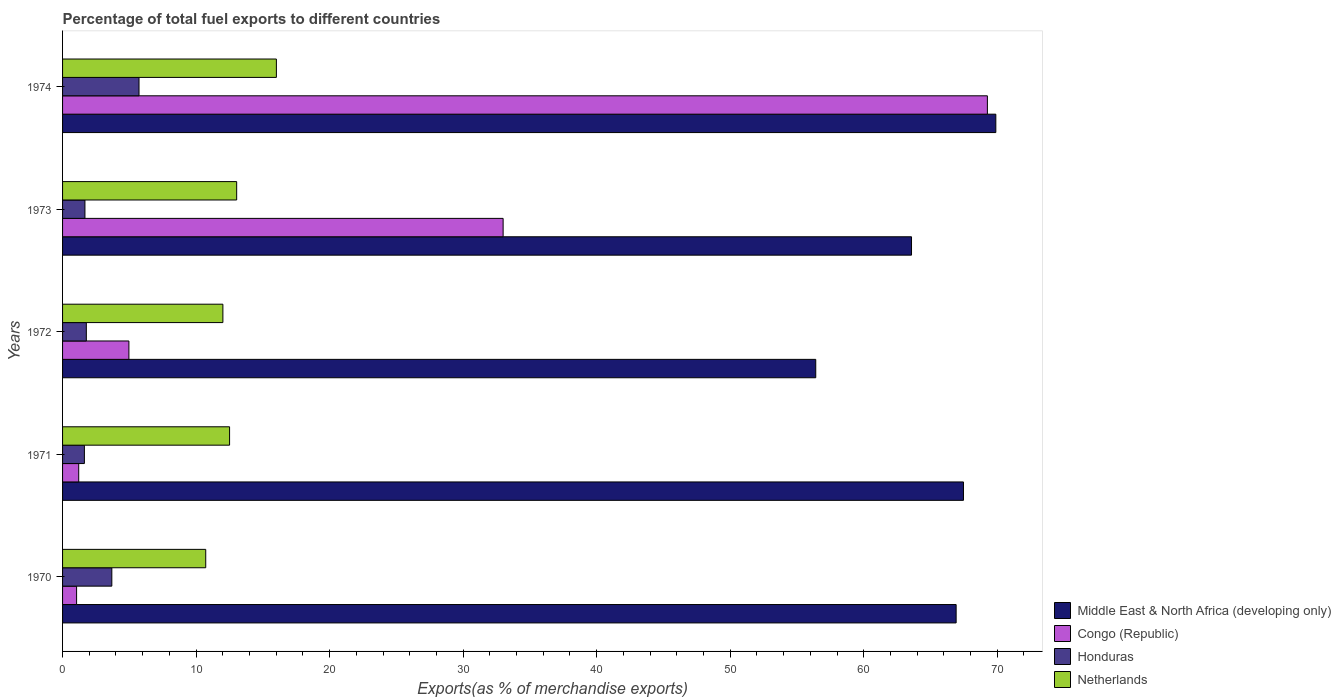How many different coloured bars are there?
Provide a succinct answer. 4. How many groups of bars are there?
Provide a short and direct response. 5. Are the number of bars on each tick of the Y-axis equal?
Your answer should be compact. Yes. How many bars are there on the 4th tick from the top?
Your answer should be compact. 4. How many bars are there on the 3rd tick from the bottom?
Give a very brief answer. 4. What is the percentage of exports to different countries in Middle East & North Africa (developing only) in 1971?
Provide a short and direct response. 67.47. Across all years, what is the maximum percentage of exports to different countries in Middle East & North Africa (developing only)?
Your answer should be compact. 69.9. Across all years, what is the minimum percentage of exports to different countries in Honduras?
Make the answer very short. 1.64. In which year was the percentage of exports to different countries in Netherlands maximum?
Provide a succinct answer. 1974. What is the total percentage of exports to different countries in Honduras in the graph?
Make the answer very short. 14.51. What is the difference between the percentage of exports to different countries in Netherlands in 1970 and that in 1972?
Offer a very short reply. -1.29. What is the difference between the percentage of exports to different countries in Netherlands in 1973 and the percentage of exports to different countries in Honduras in 1972?
Your response must be concise. 11.26. What is the average percentage of exports to different countries in Netherlands per year?
Offer a terse response. 12.86. In the year 1972, what is the difference between the percentage of exports to different countries in Middle East & North Africa (developing only) and percentage of exports to different countries in Netherlands?
Provide a succinct answer. 44.4. What is the ratio of the percentage of exports to different countries in Netherlands in 1973 to that in 1974?
Your response must be concise. 0.81. Is the percentage of exports to different countries in Middle East & North Africa (developing only) in 1970 less than that in 1972?
Your answer should be very brief. No. Is the difference between the percentage of exports to different countries in Middle East & North Africa (developing only) in 1971 and 1974 greater than the difference between the percentage of exports to different countries in Netherlands in 1971 and 1974?
Give a very brief answer. Yes. What is the difference between the highest and the second highest percentage of exports to different countries in Honduras?
Make the answer very short. 2.04. What is the difference between the highest and the lowest percentage of exports to different countries in Congo (Republic)?
Offer a very short reply. 68.21. Is the sum of the percentage of exports to different countries in Netherlands in 1971 and 1974 greater than the maximum percentage of exports to different countries in Honduras across all years?
Give a very brief answer. Yes. What does the 4th bar from the top in 1970 represents?
Give a very brief answer. Middle East & North Africa (developing only). What does the 1st bar from the bottom in 1970 represents?
Your answer should be very brief. Middle East & North Africa (developing only). Is it the case that in every year, the sum of the percentage of exports to different countries in Congo (Republic) and percentage of exports to different countries in Netherlands is greater than the percentage of exports to different countries in Honduras?
Offer a very short reply. Yes. Are all the bars in the graph horizontal?
Your answer should be very brief. Yes. What is the difference between two consecutive major ticks on the X-axis?
Your answer should be compact. 10. Are the values on the major ticks of X-axis written in scientific E-notation?
Ensure brevity in your answer.  No. Does the graph contain any zero values?
Your response must be concise. No. How many legend labels are there?
Provide a short and direct response. 4. What is the title of the graph?
Provide a succinct answer. Percentage of total fuel exports to different countries. Does "Cuba" appear as one of the legend labels in the graph?
Keep it short and to the point. No. What is the label or title of the X-axis?
Provide a short and direct response. Exports(as % of merchandise exports). What is the Exports(as % of merchandise exports) in Middle East & North Africa (developing only) in 1970?
Give a very brief answer. 66.92. What is the Exports(as % of merchandise exports) of Congo (Republic) in 1970?
Offer a terse response. 1.05. What is the Exports(as % of merchandise exports) in Honduras in 1970?
Keep it short and to the point. 3.69. What is the Exports(as % of merchandise exports) in Netherlands in 1970?
Ensure brevity in your answer.  10.72. What is the Exports(as % of merchandise exports) of Middle East & North Africa (developing only) in 1971?
Your response must be concise. 67.47. What is the Exports(as % of merchandise exports) in Congo (Republic) in 1971?
Provide a succinct answer. 1.21. What is the Exports(as % of merchandise exports) in Honduras in 1971?
Offer a terse response. 1.64. What is the Exports(as % of merchandise exports) in Netherlands in 1971?
Offer a very short reply. 12.51. What is the Exports(as % of merchandise exports) of Middle East & North Africa (developing only) in 1972?
Your answer should be compact. 56.41. What is the Exports(as % of merchandise exports) in Congo (Republic) in 1972?
Offer a very short reply. 4.97. What is the Exports(as % of merchandise exports) of Honduras in 1972?
Make the answer very short. 1.78. What is the Exports(as % of merchandise exports) in Netherlands in 1972?
Provide a short and direct response. 12.01. What is the Exports(as % of merchandise exports) of Middle East & North Africa (developing only) in 1973?
Your answer should be very brief. 63.58. What is the Exports(as % of merchandise exports) in Congo (Republic) in 1973?
Make the answer very short. 33. What is the Exports(as % of merchandise exports) of Honduras in 1973?
Offer a very short reply. 1.67. What is the Exports(as % of merchandise exports) in Netherlands in 1973?
Give a very brief answer. 13.04. What is the Exports(as % of merchandise exports) in Middle East & North Africa (developing only) in 1974?
Keep it short and to the point. 69.9. What is the Exports(as % of merchandise exports) of Congo (Republic) in 1974?
Ensure brevity in your answer.  69.26. What is the Exports(as % of merchandise exports) of Honduras in 1974?
Make the answer very short. 5.73. What is the Exports(as % of merchandise exports) in Netherlands in 1974?
Give a very brief answer. 16.01. Across all years, what is the maximum Exports(as % of merchandise exports) of Middle East & North Africa (developing only)?
Keep it short and to the point. 69.9. Across all years, what is the maximum Exports(as % of merchandise exports) of Congo (Republic)?
Make the answer very short. 69.26. Across all years, what is the maximum Exports(as % of merchandise exports) in Honduras?
Provide a succinct answer. 5.73. Across all years, what is the maximum Exports(as % of merchandise exports) in Netherlands?
Make the answer very short. 16.01. Across all years, what is the minimum Exports(as % of merchandise exports) of Middle East & North Africa (developing only)?
Offer a terse response. 56.41. Across all years, what is the minimum Exports(as % of merchandise exports) in Congo (Republic)?
Provide a short and direct response. 1.05. Across all years, what is the minimum Exports(as % of merchandise exports) of Honduras?
Your answer should be very brief. 1.64. Across all years, what is the minimum Exports(as % of merchandise exports) of Netherlands?
Ensure brevity in your answer.  10.72. What is the total Exports(as % of merchandise exports) in Middle East & North Africa (developing only) in the graph?
Your response must be concise. 324.28. What is the total Exports(as % of merchandise exports) of Congo (Republic) in the graph?
Offer a terse response. 109.49. What is the total Exports(as % of merchandise exports) in Honduras in the graph?
Provide a succinct answer. 14.51. What is the total Exports(as % of merchandise exports) in Netherlands in the graph?
Ensure brevity in your answer.  64.29. What is the difference between the Exports(as % of merchandise exports) in Middle East & North Africa (developing only) in 1970 and that in 1971?
Offer a very short reply. -0.55. What is the difference between the Exports(as % of merchandise exports) in Congo (Republic) in 1970 and that in 1971?
Provide a short and direct response. -0.16. What is the difference between the Exports(as % of merchandise exports) of Honduras in 1970 and that in 1971?
Ensure brevity in your answer.  2.05. What is the difference between the Exports(as % of merchandise exports) of Netherlands in 1970 and that in 1971?
Provide a succinct answer. -1.79. What is the difference between the Exports(as % of merchandise exports) in Middle East & North Africa (developing only) in 1970 and that in 1972?
Ensure brevity in your answer.  10.51. What is the difference between the Exports(as % of merchandise exports) in Congo (Republic) in 1970 and that in 1972?
Offer a very short reply. -3.92. What is the difference between the Exports(as % of merchandise exports) in Honduras in 1970 and that in 1972?
Your answer should be very brief. 1.91. What is the difference between the Exports(as % of merchandise exports) in Netherlands in 1970 and that in 1972?
Your answer should be compact. -1.29. What is the difference between the Exports(as % of merchandise exports) in Middle East & North Africa (developing only) in 1970 and that in 1973?
Ensure brevity in your answer.  3.34. What is the difference between the Exports(as % of merchandise exports) of Congo (Republic) in 1970 and that in 1973?
Your answer should be very brief. -31.94. What is the difference between the Exports(as % of merchandise exports) in Honduras in 1970 and that in 1973?
Make the answer very short. 2.01. What is the difference between the Exports(as % of merchandise exports) in Netherlands in 1970 and that in 1973?
Offer a terse response. -2.32. What is the difference between the Exports(as % of merchandise exports) of Middle East & North Africa (developing only) in 1970 and that in 1974?
Keep it short and to the point. -2.97. What is the difference between the Exports(as % of merchandise exports) in Congo (Republic) in 1970 and that in 1974?
Keep it short and to the point. -68.21. What is the difference between the Exports(as % of merchandise exports) in Honduras in 1970 and that in 1974?
Make the answer very short. -2.04. What is the difference between the Exports(as % of merchandise exports) of Netherlands in 1970 and that in 1974?
Make the answer very short. -5.29. What is the difference between the Exports(as % of merchandise exports) of Middle East & North Africa (developing only) in 1971 and that in 1972?
Give a very brief answer. 11.06. What is the difference between the Exports(as % of merchandise exports) of Congo (Republic) in 1971 and that in 1972?
Your answer should be compact. -3.76. What is the difference between the Exports(as % of merchandise exports) in Honduras in 1971 and that in 1972?
Provide a short and direct response. -0.14. What is the difference between the Exports(as % of merchandise exports) in Netherlands in 1971 and that in 1972?
Offer a very short reply. 0.5. What is the difference between the Exports(as % of merchandise exports) of Middle East & North Africa (developing only) in 1971 and that in 1973?
Your response must be concise. 3.89. What is the difference between the Exports(as % of merchandise exports) of Congo (Republic) in 1971 and that in 1973?
Offer a very short reply. -31.79. What is the difference between the Exports(as % of merchandise exports) of Honduras in 1971 and that in 1973?
Your answer should be very brief. -0.04. What is the difference between the Exports(as % of merchandise exports) of Netherlands in 1971 and that in 1973?
Your answer should be compact. -0.53. What is the difference between the Exports(as % of merchandise exports) in Middle East & North Africa (developing only) in 1971 and that in 1974?
Your answer should be compact. -2.42. What is the difference between the Exports(as % of merchandise exports) in Congo (Republic) in 1971 and that in 1974?
Keep it short and to the point. -68.05. What is the difference between the Exports(as % of merchandise exports) in Honduras in 1971 and that in 1974?
Make the answer very short. -4.09. What is the difference between the Exports(as % of merchandise exports) of Netherlands in 1971 and that in 1974?
Your answer should be compact. -3.51. What is the difference between the Exports(as % of merchandise exports) in Middle East & North Africa (developing only) in 1972 and that in 1973?
Offer a very short reply. -7.17. What is the difference between the Exports(as % of merchandise exports) of Congo (Republic) in 1972 and that in 1973?
Your answer should be compact. -28.03. What is the difference between the Exports(as % of merchandise exports) in Honduras in 1972 and that in 1973?
Offer a terse response. 0.1. What is the difference between the Exports(as % of merchandise exports) in Netherlands in 1972 and that in 1973?
Your answer should be compact. -1.03. What is the difference between the Exports(as % of merchandise exports) in Middle East & North Africa (developing only) in 1972 and that in 1974?
Provide a short and direct response. -13.49. What is the difference between the Exports(as % of merchandise exports) of Congo (Republic) in 1972 and that in 1974?
Make the answer very short. -64.3. What is the difference between the Exports(as % of merchandise exports) in Honduras in 1972 and that in 1974?
Offer a terse response. -3.95. What is the difference between the Exports(as % of merchandise exports) of Netherlands in 1972 and that in 1974?
Keep it short and to the point. -4.01. What is the difference between the Exports(as % of merchandise exports) of Middle East & North Africa (developing only) in 1973 and that in 1974?
Keep it short and to the point. -6.31. What is the difference between the Exports(as % of merchandise exports) in Congo (Republic) in 1973 and that in 1974?
Ensure brevity in your answer.  -36.27. What is the difference between the Exports(as % of merchandise exports) of Honduras in 1973 and that in 1974?
Offer a terse response. -4.05. What is the difference between the Exports(as % of merchandise exports) of Netherlands in 1973 and that in 1974?
Offer a terse response. -2.97. What is the difference between the Exports(as % of merchandise exports) in Middle East & North Africa (developing only) in 1970 and the Exports(as % of merchandise exports) in Congo (Republic) in 1971?
Your response must be concise. 65.71. What is the difference between the Exports(as % of merchandise exports) of Middle East & North Africa (developing only) in 1970 and the Exports(as % of merchandise exports) of Honduras in 1971?
Offer a terse response. 65.29. What is the difference between the Exports(as % of merchandise exports) of Middle East & North Africa (developing only) in 1970 and the Exports(as % of merchandise exports) of Netherlands in 1971?
Give a very brief answer. 54.42. What is the difference between the Exports(as % of merchandise exports) in Congo (Republic) in 1970 and the Exports(as % of merchandise exports) in Honduras in 1971?
Make the answer very short. -0.58. What is the difference between the Exports(as % of merchandise exports) in Congo (Republic) in 1970 and the Exports(as % of merchandise exports) in Netherlands in 1971?
Provide a succinct answer. -11.46. What is the difference between the Exports(as % of merchandise exports) of Honduras in 1970 and the Exports(as % of merchandise exports) of Netherlands in 1971?
Ensure brevity in your answer.  -8.82. What is the difference between the Exports(as % of merchandise exports) in Middle East & North Africa (developing only) in 1970 and the Exports(as % of merchandise exports) in Congo (Republic) in 1972?
Your answer should be very brief. 61.95. What is the difference between the Exports(as % of merchandise exports) of Middle East & North Africa (developing only) in 1970 and the Exports(as % of merchandise exports) of Honduras in 1972?
Your answer should be very brief. 65.14. What is the difference between the Exports(as % of merchandise exports) of Middle East & North Africa (developing only) in 1970 and the Exports(as % of merchandise exports) of Netherlands in 1972?
Provide a succinct answer. 54.92. What is the difference between the Exports(as % of merchandise exports) in Congo (Republic) in 1970 and the Exports(as % of merchandise exports) in Honduras in 1972?
Offer a terse response. -0.73. What is the difference between the Exports(as % of merchandise exports) of Congo (Republic) in 1970 and the Exports(as % of merchandise exports) of Netherlands in 1972?
Keep it short and to the point. -10.96. What is the difference between the Exports(as % of merchandise exports) of Honduras in 1970 and the Exports(as % of merchandise exports) of Netherlands in 1972?
Your response must be concise. -8.32. What is the difference between the Exports(as % of merchandise exports) in Middle East & North Africa (developing only) in 1970 and the Exports(as % of merchandise exports) in Congo (Republic) in 1973?
Give a very brief answer. 33.93. What is the difference between the Exports(as % of merchandise exports) in Middle East & North Africa (developing only) in 1970 and the Exports(as % of merchandise exports) in Honduras in 1973?
Provide a short and direct response. 65.25. What is the difference between the Exports(as % of merchandise exports) of Middle East & North Africa (developing only) in 1970 and the Exports(as % of merchandise exports) of Netherlands in 1973?
Ensure brevity in your answer.  53.88. What is the difference between the Exports(as % of merchandise exports) of Congo (Republic) in 1970 and the Exports(as % of merchandise exports) of Honduras in 1973?
Your response must be concise. -0.62. What is the difference between the Exports(as % of merchandise exports) in Congo (Republic) in 1970 and the Exports(as % of merchandise exports) in Netherlands in 1973?
Your answer should be very brief. -11.99. What is the difference between the Exports(as % of merchandise exports) in Honduras in 1970 and the Exports(as % of merchandise exports) in Netherlands in 1973?
Offer a terse response. -9.35. What is the difference between the Exports(as % of merchandise exports) of Middle East & North Africa (developing only) in 1970 and the Exports(as % of merchandise exports) of Congo (Republic) in 1974?
Your answer should be compact. -2.34. What is the difference between the Exports(as % of merchandise exports) of Middle East & North Africa (developing only) in 1970 and the Exports(as % of merchandise exports) of Honduras in 1974?
Your answer should be very brief. 61.2. What is the difference between the Exports(as % of merchandise exports) of Middle East & North Africa (developing only) in 1970 and the Exports(as % of merchandise exports) of Netherlands in 1974?
Offer a terse response. 50.91. What is the difference between the Exports(as % of merchandise exports) of Congo (Republic) in 1970 and the Exports(as % of merchandise exports) of Honduras in 1974?
Provide a succinct answer. -4.68. What is the difference between the Exports(as % of merchandise exports) of Congo (Republic) in 1970 and the Exports(as % of merchandise exports) of Netherlands in 1974?
Provide a short and direct response. -14.96. What is the difference between the Exports(as % of merchandise exports) of Honduras in 1970 and the Exports(as % of merchandise exports) of Netherlands in 1974?
Your answer should be compact. -12.32. What is the difference between the Exports(as % of merchandise exports) in Middle East & North Africa (developing only) in 1971 and the Exports(as % of merchandise exports) in Congo (Republic) in 1972?
Your response must be concise. 62.5. What is the difference between the Exports(as % of merchandise exports) in Middle East & North Africa (developing only) in 1971 and the Exports(as % of merchandise exports) in Honduras in 1972?
Your answer should be very brief. 65.69. What is the difference between the Exports(as % of merchandise exports) of Middle East & North Africa (developing only) in 1971 and the Exports(as % of merchandise exports) of Netherlands in 1972?
Give a very brief answer. 55.46. What is the difference between the Exports(as % of merchandise exports) of Congo (Republic) in 1971 and the Exports(as % of merchandise exports) of Honduras in 1972?
Keep it short and to the point. -0.57. What is the difference between the Exports(as % of merchandise exports) of Congo (Republic) in 1971 and the Exports(as % of merchandise exports) of Netherlands in 1972?
Ensure brevity in your answer.  -10.8. What is the difference between the Exports(as % of merchandise exports) of Honduras in 1971 and the Exports(as % of merchandise exports) of Netherlands in 1972?
Provide a short and direct response. -10.37. What is the difference between the Exports(as % of merchandise exports) of Middle East & North Africa (developing only) in 1971 and the Exports(as % of merchandise exports) of Congo (Republic) in 1973?
Ensure brevity in your answer.  34.48. What is the difference between the Exports(as % of merchandise exports) in Middle East & North Africa (developing only) in 1971 and the Exports(as % of merchandise exports) in Honduras in 1973?
Offer a very short reply. 65.8. What is the difference between the Exports(as % of merchandise exports) in Middle East & North Africa (developing only) in 1971 and the Exports(as % of merchandise exports) in Netherlands in 1973?
Ensure brevity in your answer.  54.43. What is the difference between the Exports(as % of merchandise exports) of Congo (Republic) in 1971 and the Exports(as % of merchandise exports) of Honduras in 1973?
Your response must be concise. -0.47. What is the difference between the Exports(as % of merchandise exports) of Congo (Republic) in 1971 and the Exports(as % of merchandise exports) of Netherlands in 1973?
Your answer should be compact. -11.83. What is the difference between the Exports(as % of merchandise exports) of Honduras in 1971 and the Exports(as % of merchandise exports) of Netherlands in 1973?
Ensure brevity in your answer.  -11.4. What is the difference between the Exports(as % of merchandise exports) in Middle East & North Africa (developing only) in 1971 and the Exports(as % of merchandise exports) in Congo (Republic) in 1974?
Make the answer very short. -1.79. What is the difference between the Exports(as % of merchandise exports) in Middle East & North Africa (developing only) in 1971 and the Exports(as % of merchandise exports) in Honduras in 1974?
Give a very brief answer. 61.75. What is the difference between the Exports(as % of merchandise exports) in Middle East & North Africa (developing only) in 1971 and the Exports(as % of merchandise exports) in Netherlands in 1974?
Keep it short and to the point. 51.46. What is the difference between the Exports(as % of merchandise exports) of Congo (Republic) in 1971 and the Exports(as % of merchandise exports) of Honduras in 1974?
Your answer should be very brief. -4.52. What is the difference between the Exports(as % of merchandise exports) of Congo (Republic) in 1971 and the Exports(as % of merchandise exports) of Netherlands in 1974?
Your answer should be compact. -14.8. What is the difference between the Exports(as % of merchandise exports) in Honduras in 1971 and the Exports(as % of merchandise exports) in Netherlands in 1974?
Provide a short and direct response. -14.38. What is the difference between the Exports(as % of merchandise exports) in Middle East & North Africa (developing only) in 1972 and the Exports(as % of merchandise exports) in Congo (Republic) in 1973?
Offer a terse response. 23.41. What is the difference between the Exports(as % of merchandise exports) in Middle East & North Africa (developing only) in 1972 and the Exports(as % of merchandise exports) in Honduras in 1973?
Your response must be concise. 54.73. What is the difference between the Exports(as % of merchandise exports) of Middle East & North Africa (developing only) in 1972 and the Exports(as % of merchandise exports) of Netherlands in 1973?
Ensure brevity in your answer.  43.37. What is the difference between the Exports(as % of merchandise exports) in Congo (Republic) in 1972 and the Exports(as % of merchandise exports) in Honduras in 1973?
Your response must be concise. 3.29. What is the difference between the Exports(as % of merchandise exports) of Congo (Republic) in 1972 and the Exports(as % of merchandise exports) of Netherlands in 1973?
Your answer should be very brief. -8.07. What is the difference between the Exports(as % of merchandise exports) in Honduras in 1972 and the Exports(as % of merchandise exports) in Netherlands in 1973?
Make the answer very short. -11.26. What is the difference between the Exports(as % of merchandise exports) in Middle East & North Africa (developing only) in 1972 and the Exports(as % of merchandise exports) in Congo (Republic) in 1974?
Keep it short and to the point. -12.86. What is the difference between the Exports(as % of merchandise exports) of Middle East & North Africa (developing only) in 1972 and the Exports(as % of merchandise exports) of Honduras in 1974?
Provide a succinct answer. 50.68. What is the difference between the Exports(as % of merchandise exports) of Middle East & North Africa (developing only) in 1972 and the Exports(as % of merchandise exports) of Netherlands in 1974?
Provide a short and direct response. 40.39. What is the difference between the Exports(as % of merchandise exports) of Congo (Republic) in 1972 and the Exports(as % of merchandise exports) of Honduras in 1974?
Your answer should be compact. -0.76. What is the difference between the Exports(as % of merchandise exports) in Congo (Republic) in 1972 and the Exports(as % of merchandise exports) in Netherlands in 1974?
Provide a short and direct response. -11.05. What is the difference between the Exports(as % of merchandise exports) in Honduras in 1972 and the Exports(as % of merchandise exports) in Netherlands in 1974?
Give a very brief answer. -14.23. What is the difference between the Exports(as % of merchandise exports) of Middle East & North Africa (developing only) in 1973 and the Exports(as % of merchandise exports) of Congo (Republic) in 1974?
Your response must be concise. -5.68. What is the difference between the Exports(as % of merchandise exports) in Middle East & North Africa (developing only) in 1973 and the Exports(as % of merchandise exports) in Honduras in 1974?
Your answer should be very brief. 57.85. What is the difference between the Exports(as % of merchandise exports) of Middle East & North Africa (developing only) in 1973 and the Exports(as % of merchandise exports) of Netherlands in 1974?
Keep it short and to the point. 47.57. What is the difference between the Exports(as % of merchandise exports) of Congo (Republic) in 1973 and the Exports(as % of merchandise exports) of Honduras in 1974?
Your answer should be very brief. 27.27. What is the difference between the Exports(as % of merchandise exports) in Congo (Republic) in 1973 and the Exports(as % of merchandise exports) in Netherlands in 1974?
Your answer should be compact. 16.98. What is the difference between the Exports(as % of merchandise exports) in Honduras in 1973 and the Exports(as % of merchandise exports) in Netherlands in 1974?
Your answer should be compact. -14.34. What is the average Exports(as % of merchandise exports) in Middle East & North Africa (developing only) per year?
Your response must be concise. 64.86. What is the average Exports(as % of merchandise exports) in Congo (Republic) per year?
Provide a short and direct response. 21.9. What is the average Exports(as % of merchandise exports) of Honduras per year?
Your answer should be compact. 2.9. What is the average Exports(as % of merchandise exports) of Netherlands per year?
Provide a short and direct response. 12.86. In the year 1970, what is the difference between the Exports(as % of merchandise exports) of Middle East & North Africa (developing only) and Exports(as % of merchandise exports) of Congo (Republic)?
Offer a very short reply. 65.87. In the year 1970, what is the difference between the Exports(as % of merchandise exports) of Middle East & North Africa (developing only) and Exports(as % of merchandise exports) of Honduras?
Offer a terse response. 63.23. In the year 1970, what is the difference between the Exports(as % of merchandise exports) in Middle East & North Africa (developing only) and Exports(as % of merchandise exports) in Netherlands?
Your answer should be compact. 56.2. In the year 1970, what is the difference between the Exports(as % of merchandise exports) in Congo (Republic) and Exports(as % of merchandise exports) in Honduras?
Your answer should be very brief. -2.64. In the year 1970, what is the difference between the Exports(as % of merchandise exports) of Congo (Republic) and Exports(as % of merchandise exports) of Netherlands?
Provide a succinct answer. -9.67. In the year 1970, what is the difference between the Exports(as % of merchandise exports) in Honduras and Exports(as % of merchandise exports) in Netherlands?
Provide a short and direct response. -7.03. In the year 1971, what is the difference between the Exports(as % of merchandise exports) of Middle East & North Africa (developing only) and Exports(as % of merchandise exports) of Congo (Republic)?
Offer a terse response. 66.26. In the year 1971, what is the difference between the Exports(as % of merchandise exports) of Middle East & North Africa (developing only) and Exports(as % of merchandise exports) of Honduras?
Keep it short and to the point. 65.84. In the year 1971, what is the difference between the Exports(as % of merchandise exports) in Middle East & North Africa (developing only) and Exports(as % of merchandise exports) in Netherlands?
Offer a very short reply. 54.96. In the year 1971, what is the difference between the Exports(as % of merchandise exports) in Congo (Republic) and Exports(as % of merchandise exports) in Honduras?
Give a very brief answer. -0.43. In the year 1971, what is the difference between the Exports(as % of merchandise exports) in Congo (Republic) and Exports(as % of merchandise exports) in Netherlands?
Your answer should be very brief. -11.3. In the year 1971, what is the difference between the Exports(as % of merchandise exports) of Honduras and Exports(as % of merchandise exports) of Netherlands?
Make the answer very short. -10.87. In the year 1972, what is the difference between the Exports(as % of merchandise exports) in Middle East & North Africa (developing only) and Exports(as % of merchandise exports) in Congo (Republic)?
Your response must be concise. 51.44. In the year 1972, what is the difference between the Exports(as % of merchandise exports) in Middle East & North Africa (developing only) and Exports(as % of merchandise exports) in Honduras?
Ensure brevity in your answer.  54.63. In the year 1972, what is the difference between the Exports(as % of merchandise exports) in Middle East & North Africa (developing only) and Exports(as % of merchandise exports) in Netherlands?
Offer a very short reply. 44.4. In the year 1972, what is the difference between the Exports(as % of merchandise exports) of Congo (Republic) and Exports(as % of merchandise exports) of Honduras?
Make the answer very short. 3.19. In the year 1972, what is the difference between the Exports(as % of merchandise exports) in Congo (Republic) and Exports(as % of merchandise exports) in Netherlands?
Offer a terse response. -7.04. In the year 1972, what is the difference between the Exports(as % of merchandise exports) of Honduras and Exports(as % of merchandise exports) of Netherlands?
Provide a short and direct response. -10.23. In the year 1973, what is the difference between the Exports(as % of merchandise exports) of Middle East & North Africa (developing only) and Exports(as % of merchandise exports) of Congo (Republic)?
Make the answer very short. 30.59. In the year 1973, what is the difference between the Exports(as % of merchandise exports) of Middle East & North Africa (developing only) and Exports(as % of merchandise exports) of Honduras?
Your answer should be compact. 61.91. In the year 1973, what is the difference between the Exports(as % of merchandise exports) of Middle East & North Africa (developing only) and Exports(as % of merchandise exports) of Netherlands?
Your answer should be compact. 50.54. In the year 1973, what is the difference between the Exports(as % of merchandise exports) of Congo (Republic) and Exports(as % of merchandise exports) of Honduras?
Provide a succinct answer. 31.32. In the year 1973, what is the difference between the Exports(as % of merchandise exports) in Congo (Republic) and Exports(as % of merchandise exports) in Netherlands?
Give a very brief answer. 19.96. In the year 1973, what is the difference between the Exports(as % of merchandise exports) of Honduras and Exports(as % of merchandise exports) of Netherlands?
Your answer should be compact. -11.36. In the year 1974, what is the difference between the Exports(as % of merchandise exports) of Middle East & North Africa (developing only) and Exports(as % of merchandise exports) of Congo (Republic)?
Ensure brevity in your answer.  0.63. In the year 1974, what is the difference between the Exports(as % of merchandise exports) in Middle East & North Africa (developing only) and Exports(as % of merchandise exports) in Honduras?
Provide a succinct answer. 64.17. In the year 1974, what is the difference between the Exports(as % of merchandise exports) of Middle East & North Africa (developing only) and Exports(as % of merchandise exports) of Netherlands?
Ensure brevity in your answer.  53.88. In the year 1974, what is the difference between the Exports(as % of merchandise exports) of Congo (Republic) and Exports(as % of merchandise exports) of Honduras?
Make the answer very short. 63.54. In the year 1974, what is the difference between the Exports(as % of merchandise exports) of Congo (Republic) and Exports(as % of merchandise exports) of Netherlands?
Provide a short and direct response. 53.25. In the year 1974, what is the difference between the Exports(as % of merchandise exports) of Honduras and Exports(as % of merchandise exports) of Netherlands?
Your answer should be very brief. -10.29. What is the ratio of the Exports(as % of merchandise exports) in Middle East & North Africa (developing only) in 1970 to that in 1971?
Your response must be concise. 0.99. What is the ratio of the Exports(as % of merchandise exports) in Congo (Republic) in 1970 to that in 1971?
Your response must be concise. 0.87. What is the ratio of the Exports(as % of merchandise exports) of Honduras in 1970 to that in 1971?
Ensure brevity in your answer.  2.26. What is the ratio of the Exports(as % of merchandise exports) in Netherlands in 1970 to that in 1971?
Ensure brevity in your answer.  0.86. What is the ratio of the Exports(as % of merchandise exports) in Middle East & North Africa (developing only) in 1970 to that in 1972?
Make the answer very short. 1.19. What is the ratio of the Exports(as % of merchandise exports) of Congo (Republic) in 1970 to that in 1972?
Ensure brevity in your answer.  0.21. What is the ratio of the Exports(as % of merchandise exports) in Honduras in 1970 to that in 1972?
Provide a short and direct response. 2.07. What is the ratio of the Exports(as % of merchandise exports) in Netherlands in 1970 to that in 1972?
Provide a short and direct response. 0.89. What is the ratio of the Exports(as % of merchandise exports) in Middle East & North Africa (developing only) in 1970 to that in 1973?
Give a very brief answer. 1.05. What is the ratio of the Exports(as % of merchandise exports) in Congo (Republic) in 1970 to that in 1973?
Give a very brief answer. 0.03. What is the ratio of the Exports(as % of merchandise exports) of Honduras in 1970 to that in 1973?
Provide a succinct answer. 2.2. What is the ratio of the Exports(as % of merchandise exports) of Netherlands in 1970 to that in 1973?
Your answer should be very brief. 0.82. What is the ratio of the Exports(as % of merchandise exports) in Middle East & North Africa (developing only) in 1970 to that in 1974?
Your answer should be very brief. 0.96. What is the ratio of the Exports(as % of merchandise exports) in Congo (Republic) in 1970 to that in 1974?
Offer a very short reply. 0.02. What is the ratio of the Exports(as % of merchandise exports) in Honduras in 1970 to that in 1974?
Make the answer very short. 0.64. What is the ratio of the Exports(as % of merchandise exports) of Netherlands in 1970 to that in 1974?
Keep it short and to the point. 0.67. What is the ratio of the Exports(as % of merchandise exports) of Middle East & North Africa (developing only) in 1971 to that in 1972?
Your answer should be very brief. 1.2. What is the ratio of the Exports(as % of merchandise exports) of Congo (Republic) in 1971 to that in 1972?
Provide a short and direct response. 0.24. What is the ratio of the Exports(as % of merchandise exports) in Honduras in 1971 to that in 1972?
Ensure brevity in your answer.  0.92. What is the ratio of the Exports(as % of merchandise exports) in Netherlands in 1971 to that in 1972?
Offer a terse response. 1.04. What is the ratio of the Exports(as % of merchandise exports) in Middle East & North Africa (developing only) in 1971 to that in 1973?
Offer a very short reply. 1.06. What is the ratio of the Exports(as % of merchandise exports) of Congo (Republic) in 1971 to that in 1973?
Give a very brief answer. 0.04. What is the ratio of the Exports(as % of merchandise exports) in Honduras in 1971 to that in 1973?
Your answer should be compact. 0.98. What is the ratio of the Exports(as % of merchandise exports) in Netherlands in 1971 to that in 1973?
Your response must be concise. 0.96. What is the ratio of the Exports(as % of merchandise exports) of Middle East & North Africa (developing only) in 1971 to that in 1974?
Ensure brevity in your answer.  0.97. What is the ratio of the Exports(as % of merchandise exports) of Congo (Republic) in 1971 to that in 1974?
Give a very brief answer. 0.02. What is the ratio of the Exports(as % of merchandise exports) in Honduras in 1971 to that in 1974?
Offer a terse response. 0.29. What is the ratio of the Exports(as % of merchandise exports) in Netherlands in 1971 to that in 1974?
Your answer should be very brief. 0.78. What is the ratio of the Exports(as % of merchandise exports) of Middle East & North Africa (developing only) in 1972 to that in 1973?
Your answer should be very brief. 0.89. What is the ratio of the Exports(as % of merchandise exports) of Congo (Republic) in 1972 to that in 1973?
Your answer should be very brief. 0.15. What is the ratio of the Exports(as % of merchandise exports) in Honduras in 1972 to that in 1973?
Make the answer very short. 1.06. What is the ratio of the Exports(as % of merchandise exports) in Netherlands in 1972 to that in 1973?
Give a very brief answer. 0.92. What is the ratio of the Exports(as % of merchandise exports) of Middle East & North Africa (developing only) in 1972 to that in 1974?
Your answer should be very brief. 0.81. What is the ratio of the Exports(as % of merchandise exports) of Congo (Republic) in 1972 to that in 1974?
Keep it short and to the point. 0.07. What is the ratio of the Exports(as % of merchandise exports) of Honduras in 1972 to that in 1974?
Make the answer very short. 0.31. What is the ratio of the Exports(as % of merchandise exports) of Netherlands in 1972 to that in 1974?
Keep it short and to the point. 0.75. What is the ratio of the Exports(as % of merchandise exports) of Middle East & North Africa (developing only) in 1973 to that in 1974?
Give a very brief answer. 0.91. What is the ratio of the Exports(as % of merchandise exports) of Congo (Republic) in 1973 to that in 1974?
Make the answer very short. 0.48. What is the ratio of the Exports(as % of merchandise exports) of Honduras in 1973 to that in 1974?
Provide a short and direct response. 0.29. What is the ratio of the Exports(as % of merchandise exports) of Netherlands in 1973 to that in 1974?
Provide a succinct answer. 0.81. What is the difference between the highest and the second highest Exports(as % of merchandise exports) in Middle East & North Africa (developing only)?
Ensure brevity in your answer.  2.42. What is the difference between the highest and the second highest Exports(as % of merchandise exports) of Congo (Republic)?
Offer a terse response. 36.27. What is the difference between the highest and the second highest Exports(as % of merchandise exports) of Honduras?
Provide a short and direct response. 2.04. What is the difference between the highest and the second highest Exports(as % of merchandise exports) of Netherlands?
Your response must be concise. 2.97. What is the difference between the highest and the lowest Exports(as % of merchandise exports) of Middle East & North Africa (developing only)?
Your answer should be compact. 13.49. What is the difference between the highest and the lowest Exports(as % of merchandise exports) of Congo (Republic)?
Provide a short and direct response. 68.21. What is the difference between the highest and the lowest Exports(as % of merchandise exports) in Honduras?
Keep it short and to the point. 4.09. What is the difference between the highest and the lowest Exports(as % of merchandise exports) of Netherlands?
Provide a short and direct response. 5.29. 